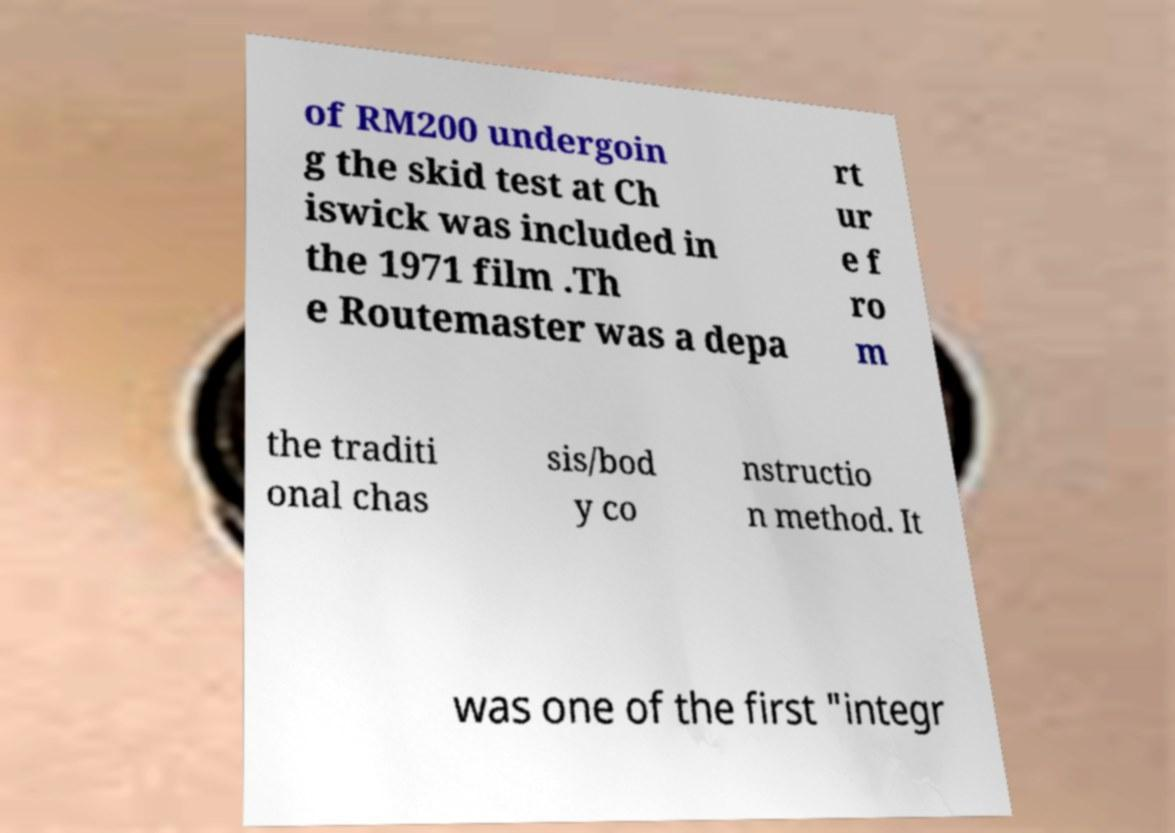Could you extract and type out the text from this image? of RM200 undergoin g the skid test at Ch iswick was included in the 1971 film .Th e Routemaster was a depa rt ur e f ro m the traditi onal chas sis/bod y co nstructio n method. It was one of the first "integr 